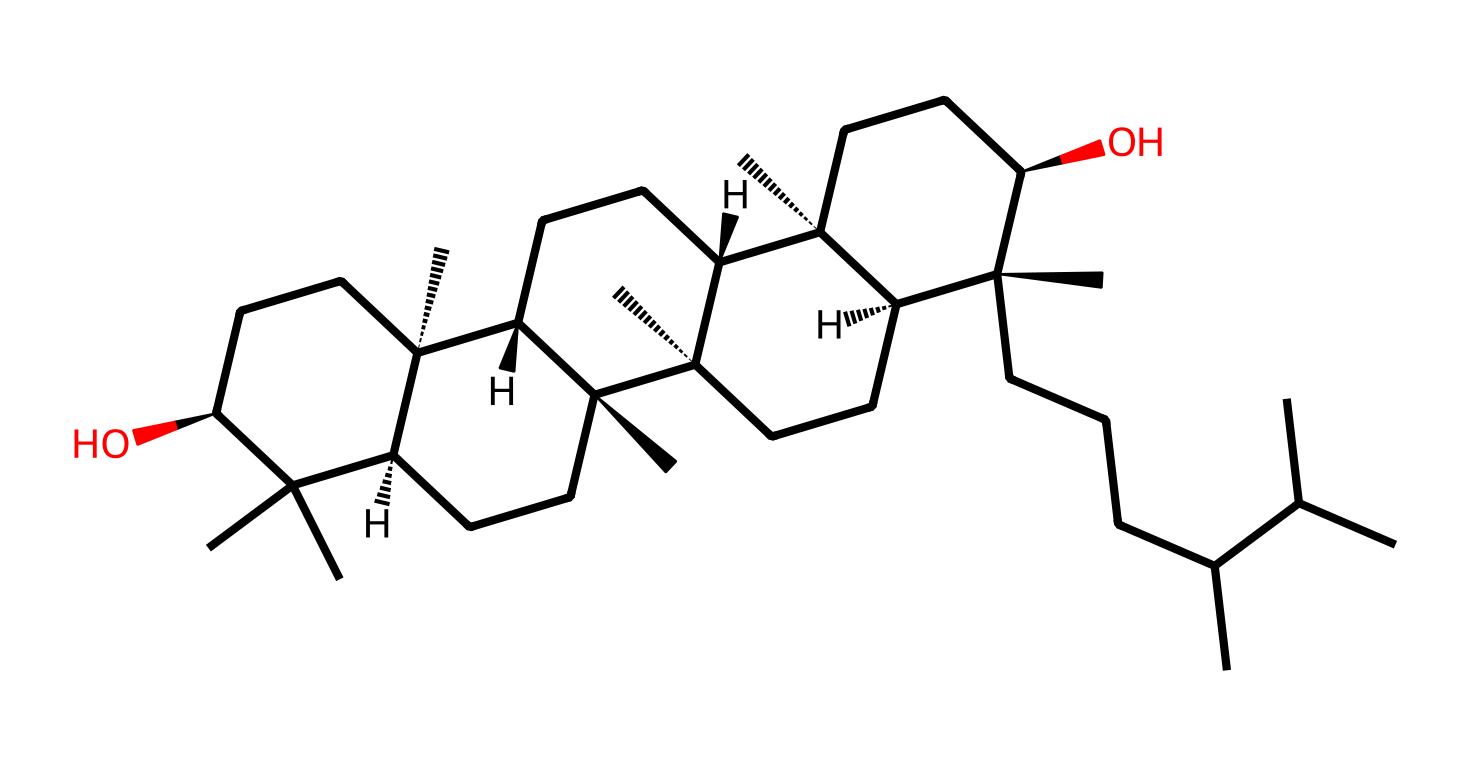what is the total number of carbon atoms in this structure? To find the total number of carbon atoms, we can visually inspect the structure to count each carbon (C) atom represented in the branches and rings of the molecule. By carefully analyzing the entire rendered structure, we find that there are 30 carbon atoms total.
Answer: 30 how many oxygen atoms are present in the molecule? By observing the structure, we focus on identifying the oxygen (O) atoms. Each oxygen atom in the structure can be noted visually, and thus we count a total of 2 oxygen atoms present in the entire structure.
Answer: 2 what functional groups are evident in the chemical structure? The chemical structure contains hydroxyl (-OH) groups, which can be identified by looking for oxygen atoms bonded to hydrogen atoms. The presence of these -OH functionalities indicates that there are alcohol groups in the molecule.
Answer: hydroxyl does the structure feature any chiral centers? Chiral centers are carbon atoms bonded to four different substituents. In this structure, we can identify several carbons with unique arrangements around them, particularly where indicated by stereochemistry notations like [C@] and [C@@]. Upon close analysis, there are 4 chiral centers in this molecule.
Answer: 4 what is the likely state of this chemical at room temperature? Given that the chemical structure is that of a varnish typically used in the art world, we can infer based on the molecular structure and its composition that it is likely to be a liquid at room temperature. This is due to the presence of various alkyl chains and functional groups that support a lower boiling point.
Answer: liquid is this chemical likely to be polar or nonpolar? To determine the polarity of the molecule, we consider the presence of functional groups and the overall shape of the molecule. The presence of multiple hydroxyl groups suggests a certain degree of polarity, but the extensive carbon chains may lead to a nonpolar characteristic overall. Upon evaluation, this structure is likely more nonpolar.
Answer: nonpolar 